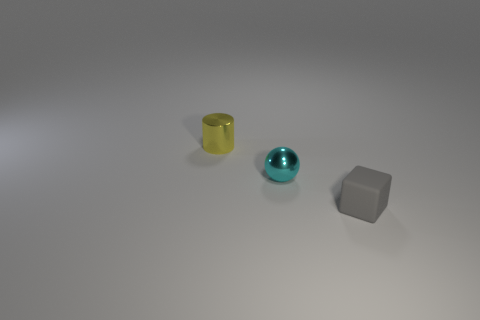Subtract all cubes. How many objects are left? 2 Subtract 1 cylinders. How many cylinders are left? 0 Subtract all small metallic things. Subtract all small cyan things. How many objects are left? 0 Add 2 cyan things. How many cyan things are left? 3 Add 3 gray cubes. How many gray cubes exist? 4 Add 3 small yellow things. How many objects exist? 6 Subtract 0 gray balls. How many objects are left? 3 Subtract all red cylinders. Subtract all gray balls. How many cylinders are left? 1 